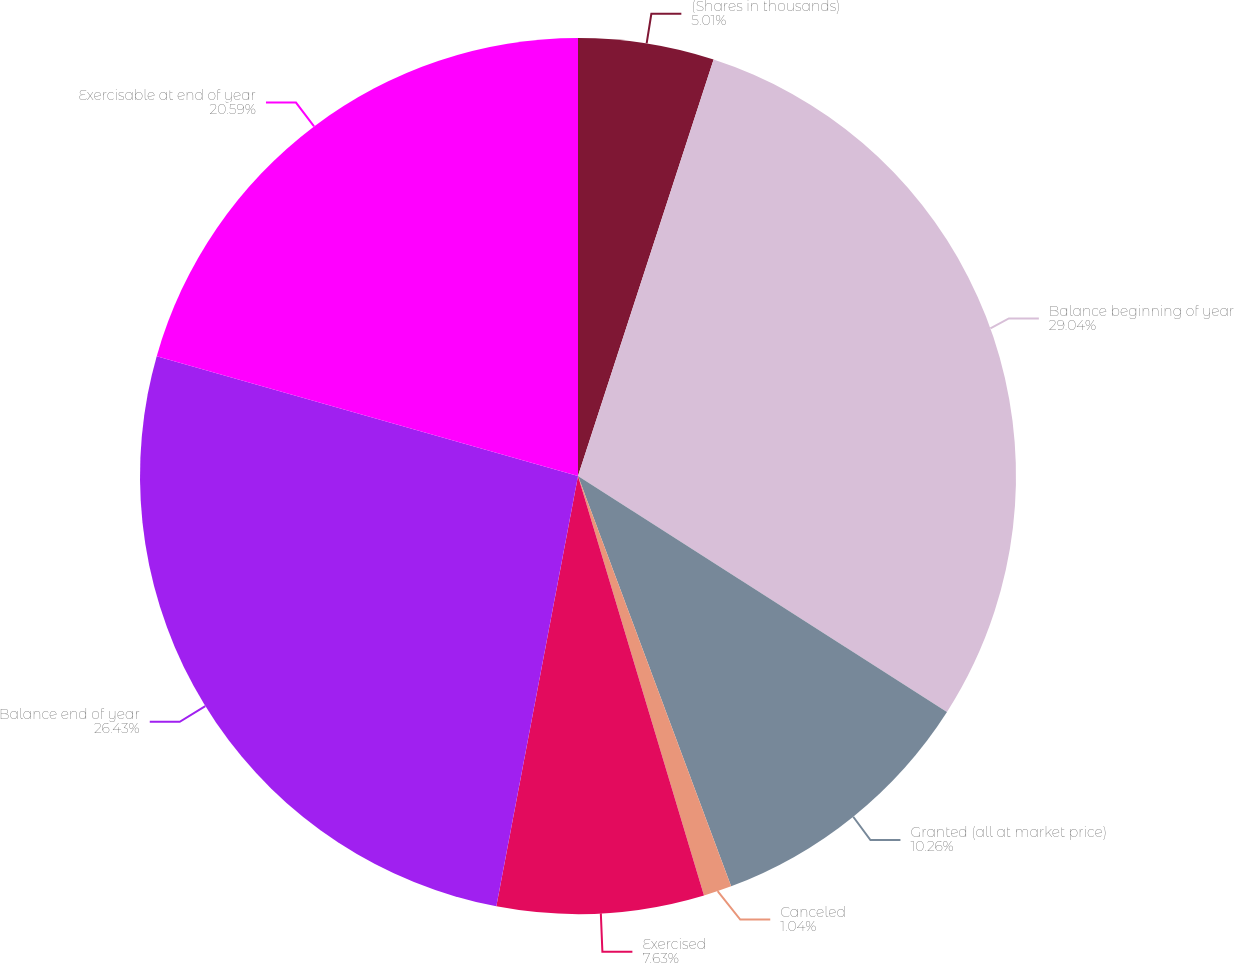<chart> <loc_0><loc_0><loc_500><loc_500><pie_chart><fcel>(Shares in thousands)<fcel>Balance beginning of year<fcel>Granted (all at market price)<fcel>Canceled<fcel>Exercised<fcel>Balance end of year<fcel>Exercisable at end of year<nl><fcel>5.01%<fcel>29.05%<fcel>10.26%<fcel>1.04%<fcel>7.63%<fcel>26.43%<fcel>20.59%<nl></chart> 